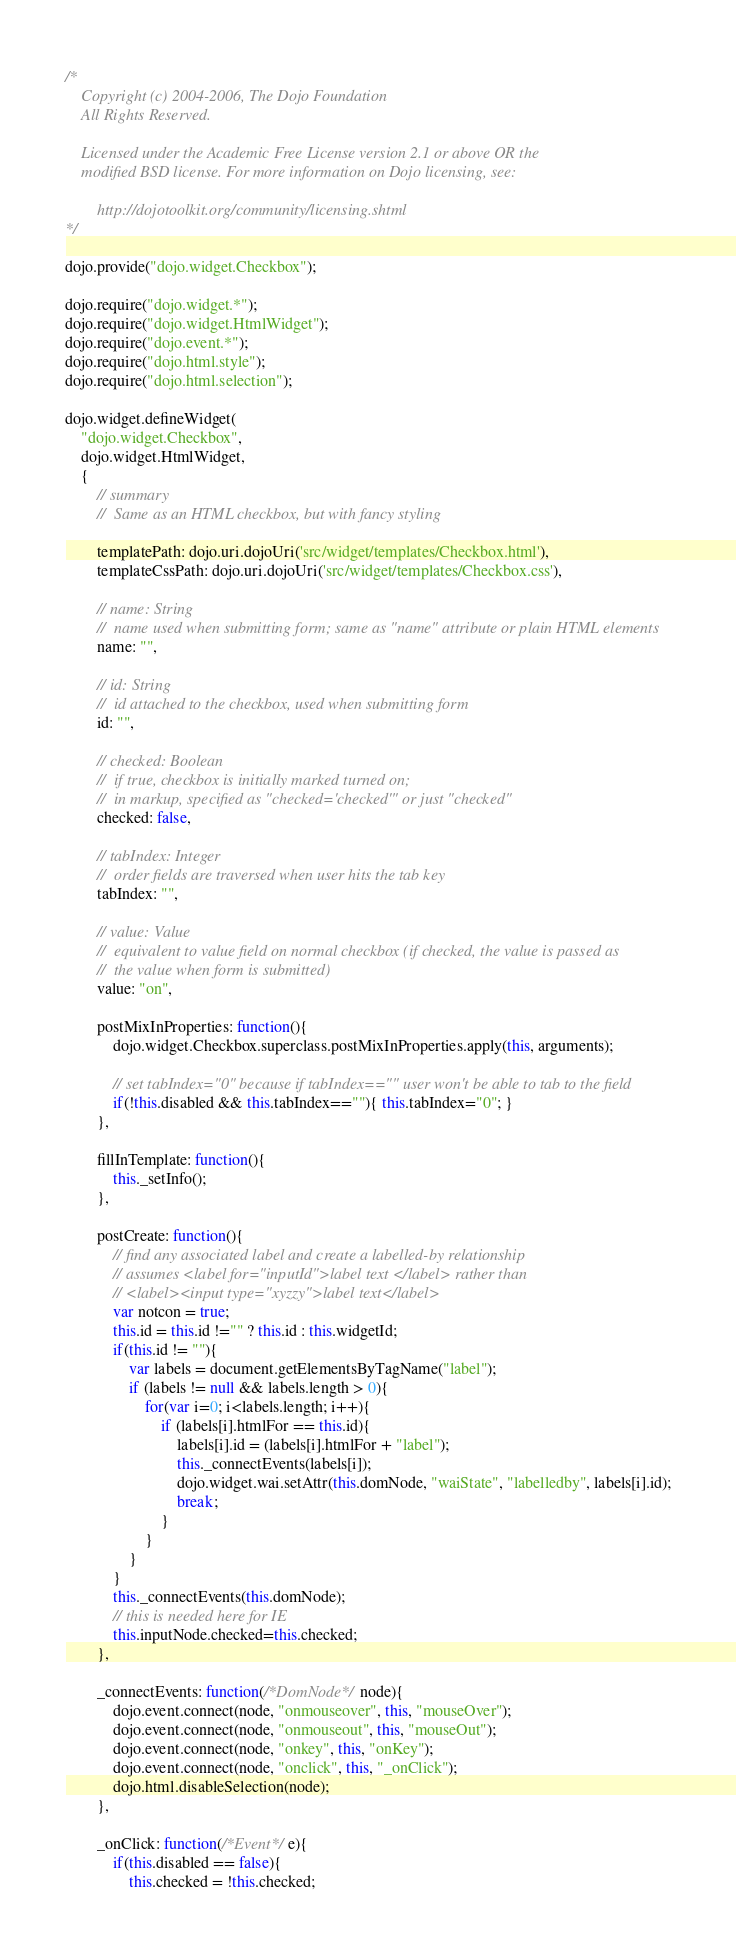Convert code to text. <code><loc_0><loc_0><loc_500><loc_500><_JavaScript_>/*
	Copyright (c) 2004-2006, The Dojo Foundation
	All Rights Reserved.

	Licensed under the Academic Free License version 2.1 or above OR the
	modified BSD license. For more information on Dojo licensing, see:

		http://dojotoolkit.org/community/licensing.shtml
*/

dojo.provide("dojo.widget.Checkbox");

dojo.require("dojo.widget.*");
dojo.require("dojo.widget.HtmlWidget");
dojo.require("dojo.event.*");
dojo.require("dojo.html.style");
dojo.require("dojo.html.selection");

dojo.widget.defineWidget(
	"dojo.widget.Checkbox",
	dojo.widget.HtmlWidget,
	{
		// summary
		//	Same as an HTML checkbox, but with fancy styling

		templatePath: dojo.uri.dojoUri('src/widget/templates/Checkbox.html'),
		templateCssPath: dojo.uri.dojoUri('src/widget/templates/Checkbox.css'),

		// name: String
		//	name used when submitting form; same as "name" attribute or plain HTML elements
		name: "",

		// id: String
		//	id attached to the checkbox, used when submitting form
		id: "",

		// checked: Boolean
		//	if true, checkbox is initially marked turned on;
		//	in markup, specified as "checked='checked'" or just "checked"
		checked: false,

		// tabIndex: Integer
		//	order fields are traversed when user hits the tab key
		tabIndex: "",

		// value: Value
		//	equivalent to value field on normal checkbox (if checked, the value is passed as
		//	the value when form is submitted)
		value: "on",

		postMixInProperties: function(){
			dojo.widget.Checkbox.superclass.postMixInProperties.apply(this, arguments);

			// set tabIndex="0" because if tabIndex=="" user won't be able to tab to the field
			if(!this.disabled && this.tabIndex==""){ this.tabIndex="0"; }
		},

		fillInTemplate: function(){
			this._setInfo();
		},

		postCreate: function(){
			// find any associated label and create a labelled-by relationship
			// assumes <label for="inputId">label text </label> rather than
			// <label><input type="xyzzy">label text</label>
			var notcon = true;
			this.id = this.id !="" ? this.id : this.widgetId;
			if(this.id != ""){
				var labels = document.getElementsByTagName("label");
				if (labels != null && labels.length > 0){
					for(var i=0; i<labels.length; i++){
						if (labels[i].htmlFor == this.id){
							labels[i].id = (labels[i].htmlFor + "label");
							this._connectEvents(labels[i]);
							dojo.widget.wai.setAttr(this.domNode, "waiState", "labelledby", labels[i].id);
							break;
						}
					}
				}
			}
			this._connectEvents(this.domNode);
			// this is needed here for IE
			this.inputNode.checked=this.checked;
		},

		_connectEvents: function(/*DomNode*/ node){
			dojo.event.connect(node, "onmouseover", this, "mouseOver");
			dojo.event.connect(node, "onmouseout", this, "mouseOut");
			dojo.event.connect(node, "onkey", this, "onKey");
			dojo.event.connect(node, "onclick", this, "_onClick");
			dojo.html.disableSelection(node);
		},

		_onClick: function(/*Event*/ e){
			if(this.disabled == false){
				this.checked = !this.checked;</code> 